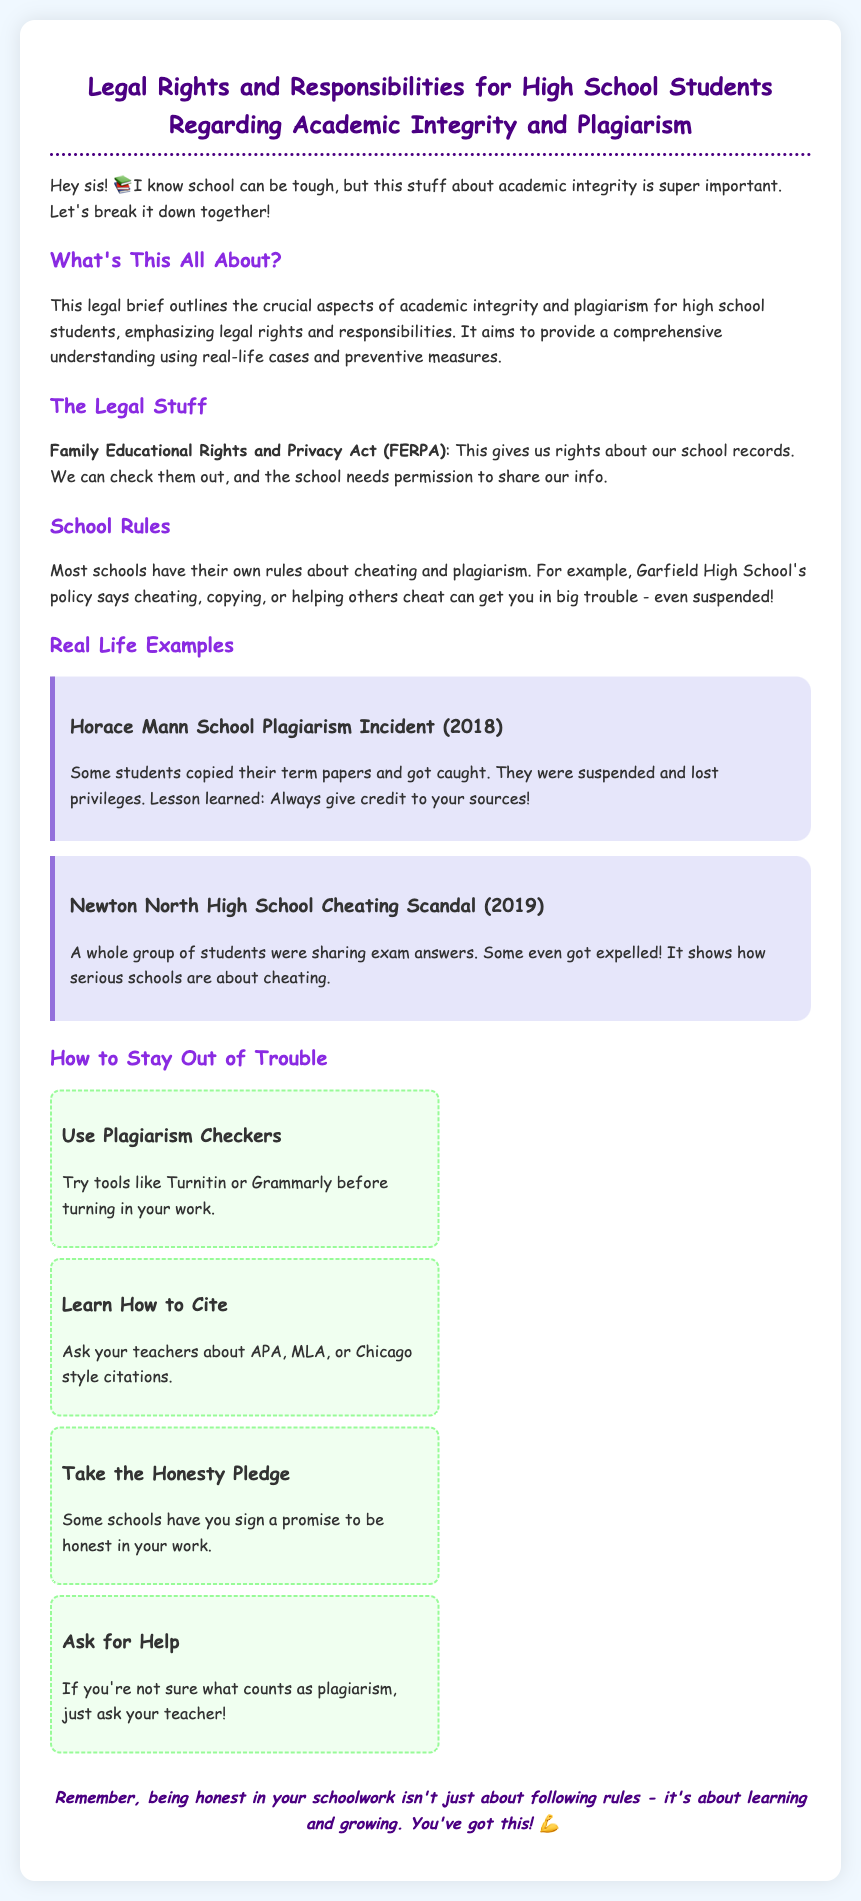What is the title of the document? The title of the document is the main heading, which describes the focus on legal rights and responsibilities for students.
Answer: Legal Rights and Responsibilities for High School Students Regarding Academic Integrity and Plagiarism What act gives rights about school records? The act mentioned provides students with rights concerning their educational records and privacy.
Answer: Family Educational Rights and Privacy Act (FERPA) What happened at Horace Mann School in 2018? This incident involved students who were caught plagiarizing and faced consequences.
Answer: Students copied their term papers and got caught How many case studies are documented? The document contains examples of relevant incidents regarding academic integrity breaches.
Answer: Two What can students use to check for plagiarism? The document suggests tools that help students ensure their work is original before submission.
Answer: Plagiarism checkers What is one way to avoid misunderstanding plagiarism? This involves seeking clarification to ensure one is aware of what constitutes plagiarism.
Answer: Ask for Help How do schools address cheating and plagiarism? The document mentions specific disciplinary actions that schools may take against cheating and plagiarism.
Answer: Suspension or expulsion What is a preventative measure mentioned in the document? The document provides specific strategies that students can adopt to maintain academic integrity.
Answer: Learn How to Cite 